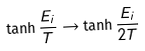Convert formula to latex. <formula><loc_0><loc_0><loc_500><loc_500>\tanh \frac { E _ { i } } { T } \rightarrow \tanh \frac { E _ { i } } { 2 T }</formula> 